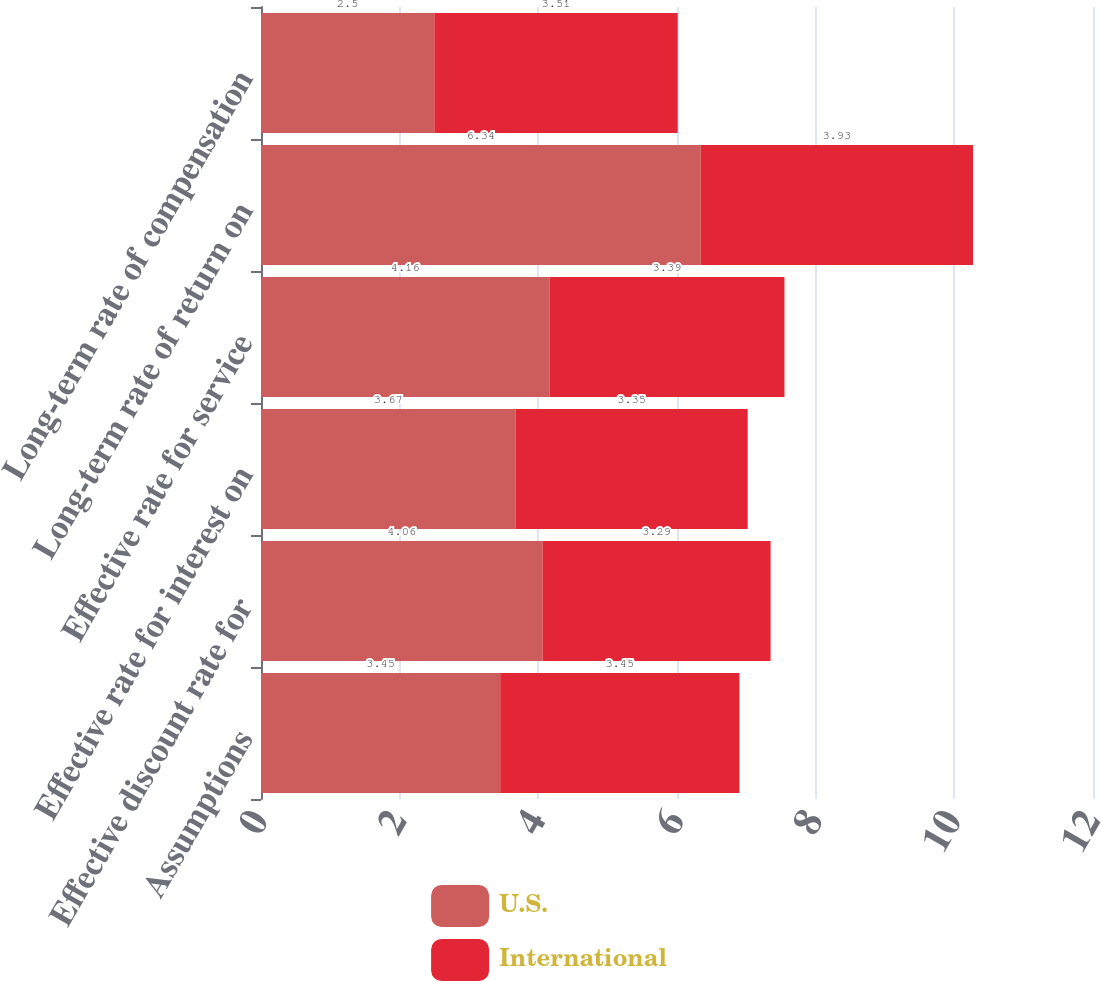Convert chart to OTSL. <chart><loc_0><loc_0><loc_500><loc_500><stacked_bar_chart><ecel><fcel>Assumptions<fcel>Effective discount rate for<fcel>Effective rate for interest on<fcel>Effective rate for service<fcel>Long-term rate of return on<fcel>Long-term rate of compensation<nl><fcel>U.S.<fcel>3.45<fcel>4.06<fcel>3.67<fcel>4.16<fcel>6.34<fcel>2.5<nl><fcel>International<fcel>3.45<fcel>3.29<fcel>3.35<fcel>3.39<fcel>3.93<fcel>3.51<nl></chart> 